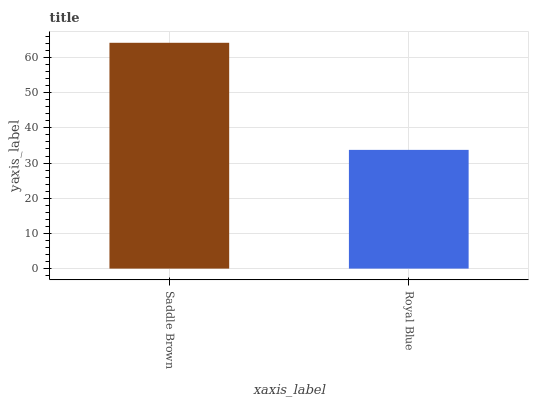Is Royal Blue the maximum?
Answer yes or no. No. Is Saddle Brown greater than Royal Blue?
Answer yes or no. Yes. Is Royal Blue less than Saddle Brown?
Answer yes or no. Yes. Is Royal Blue greater than Saddle Brown?
Answer yes or no. No. Is Saddle Brown less than Royal Blue?
Answer yes or no. No. Is Saddle Brown the high median?
Answer yes or no. Yes. Is Royal Blue the low median?
Answer yes or no. Yes. Is Royal Blue the high median?
Answer yes or no. No. Is Saddle Brown the low median?
Answer yes or no. No. 